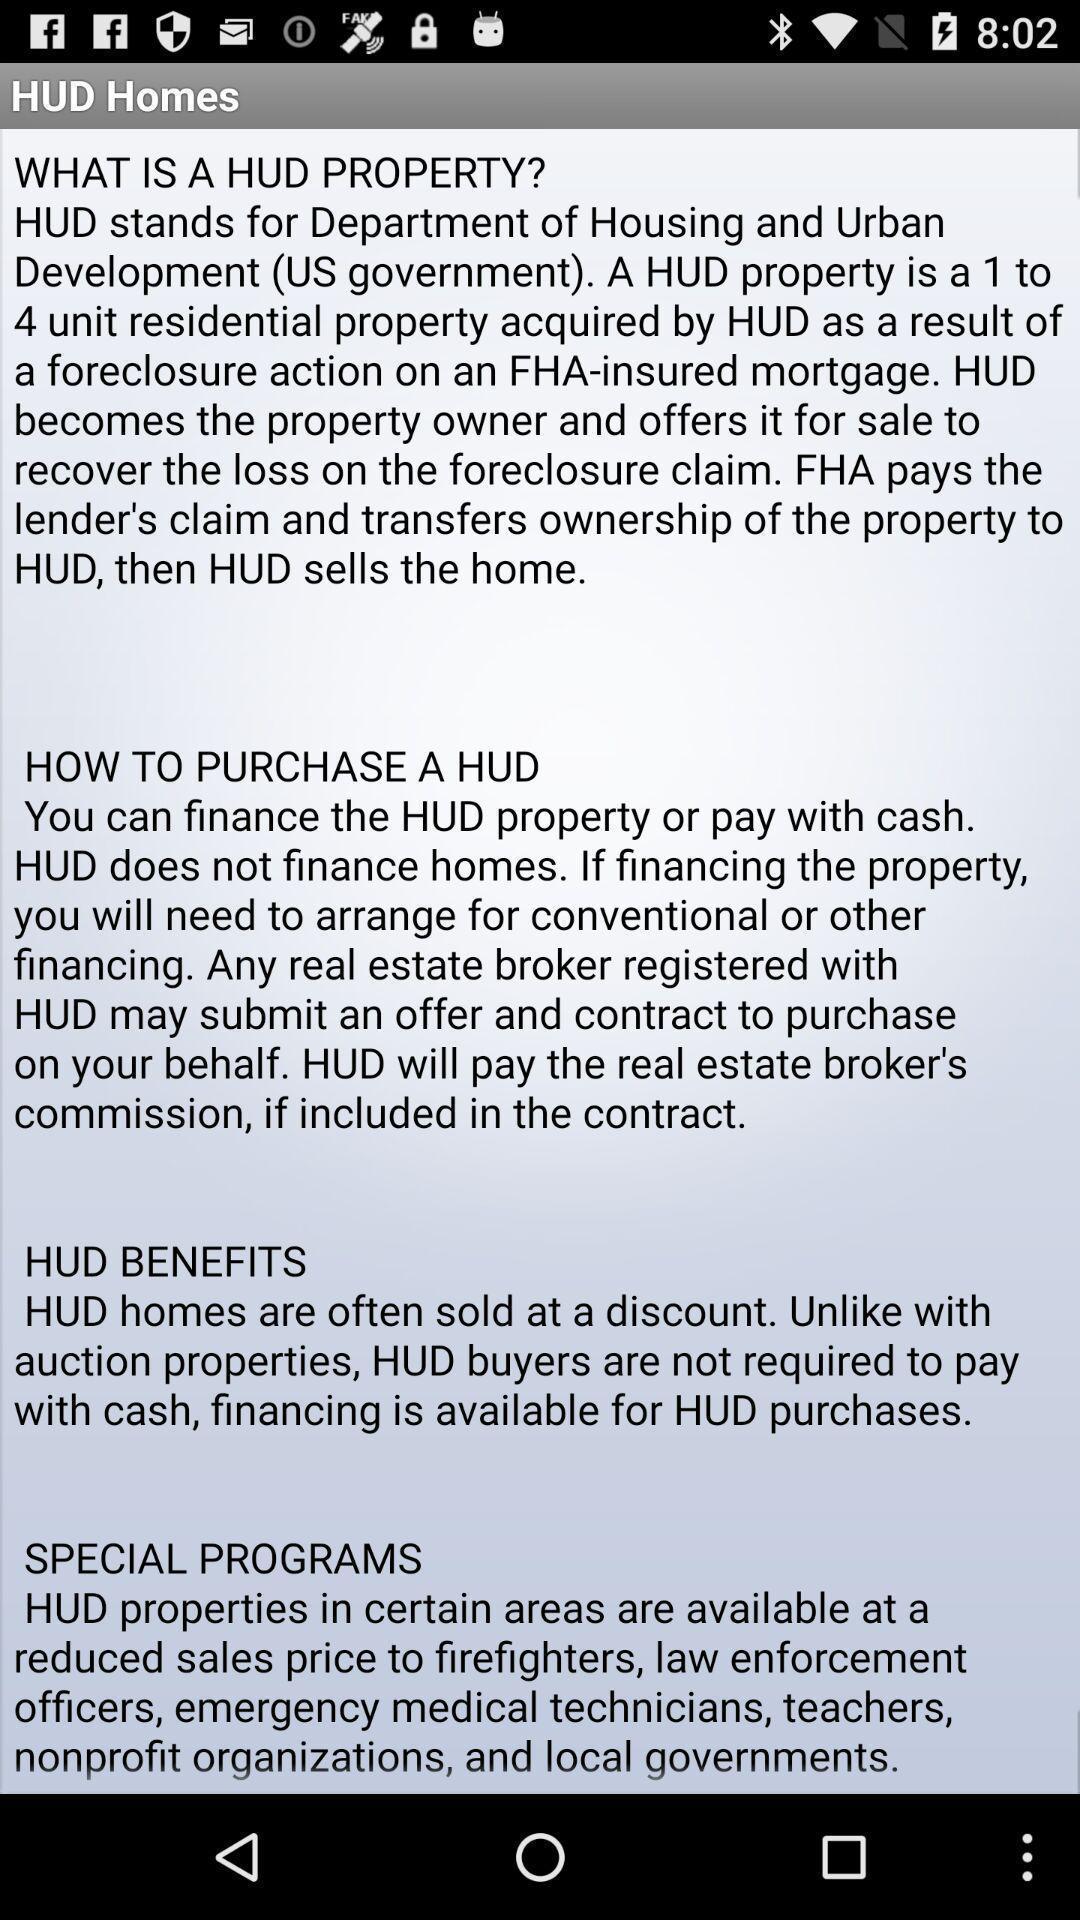Tell me about the visual elements in this screen capture. Page showing information about a housing app. 